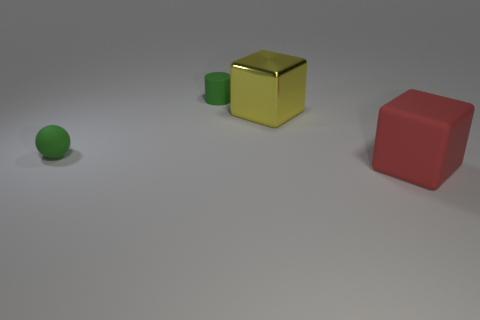The object that is on the left side of the large yellow shiny thing and in front of the large metal thing is what color?
Offer a very short reply. Green. What number of red matte cubes are behind the big yellow block?
Keep it short and to the point. 0. What material is the cylinder?
Keep it short and to the point. Rubber. There is a big object in front of the tiny thing in front of the block that is left of the red matte block; what color is it?
Keep it short and to the point. Red. What number of objects are the same size as the rubber cylinder?
Ensure brevity in your answer.  1. What color is the big block on the right side of the shiny thing?
Ensure brevity in your answer.  Red. What number of other things are the same size as the green matte cylinder?
Your answer should be very brief. 1. There is a object that is both in front of the big yellow cube and on the left side of the big red thing; what size is it?
Provide a succinct answer. Small. Do the metal thing and the tiny object behind the small ball have the same color?
Offer a terse response. No. Are there any other yellow metallic objects that have the same shape as the yellow shiny object?
Make the answer very short. No. 